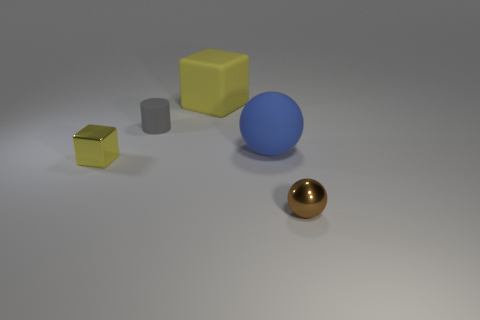Add 3 small blue metal balls. How many objects exist? 8 Subtract all cylinders. How many objects are left? 4 Add 2 red matte cubes. How many red matte cubes exist? 2 Subtract 0 purple cylinders. How many objects are left? 5 Subtract all large shiny cylinders. Subtract all rubber balls. How many objects are left? 4 Add 3 blue matte balls. How many blue matte balls are left? 4 